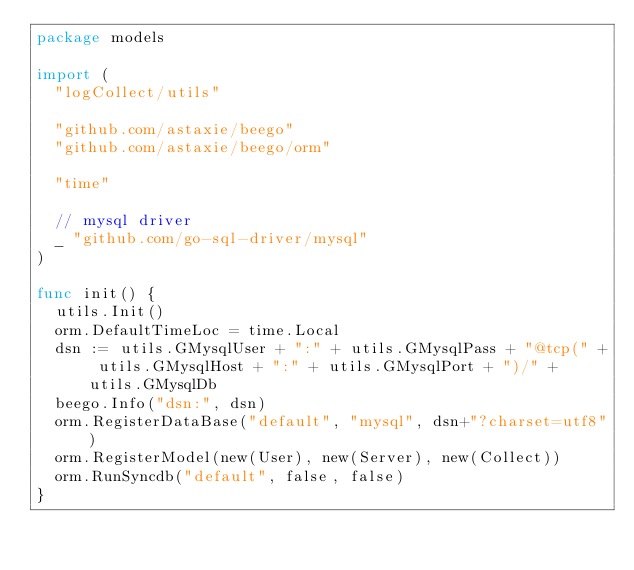<code> <loc_0><loc_0><loc_500><loc_500><_Go_>package models

import (
	"logCollect/utils"

	"github.com/astaxie/beego"
	"github.com/astaxie/beego/orm"

	"time"

	// mysql driver
	_ "github.com/go-sql-driver/mysql"
)

func init() {
	utils.Init()
	orm.DefaultTimeLoc = time.Local
	dsn := utils.GMysqlUser + ":" + utils.GMysqlPass + "@tcp(" + utils.GMysqlHost + ":" + utils.GMysqlPort + ")/" + utils.GMysqlDb
	beego.Info("dsn:", dsn)
	orm.RegisterDataBase("default", "mysql", dsn+"?charset=utf8")
	orm.RegisterModel(new(User), new(Server), new(Collect))
	orm.RunSyncdb("default", false, false)
}
</code> 